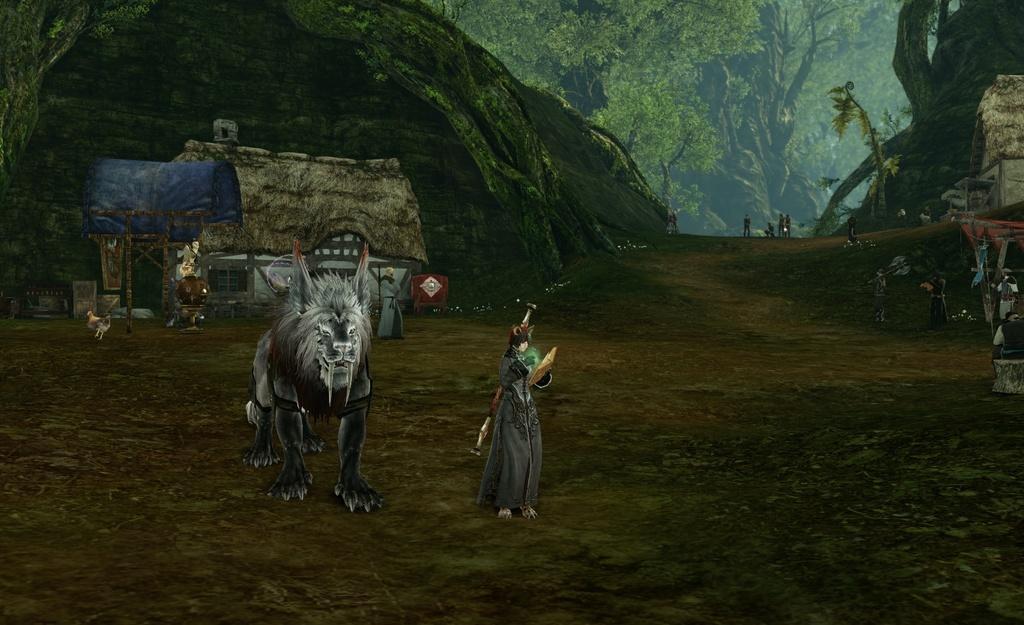Describe this image in one or two sentences. This is an animation and here we can see an animal, a bird, some people, hills, trees, sheds and there are some other objects. At the bottom, there is ground. 